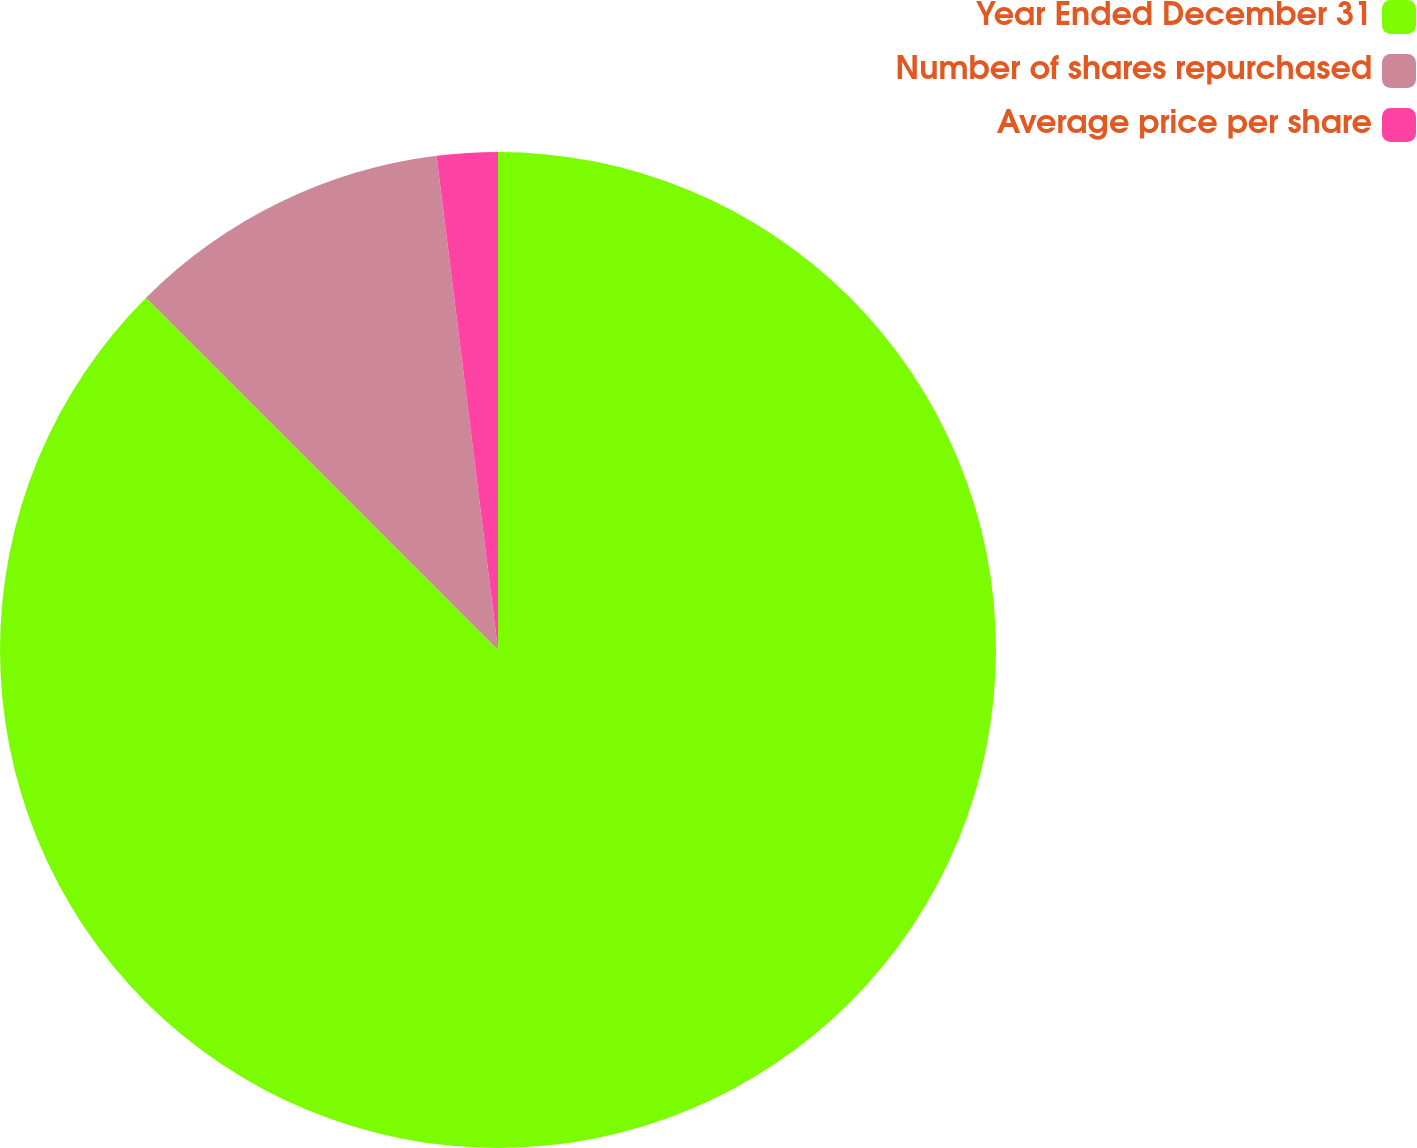Convert chart. <chart><loc_0><loc_0><loc_500><loc_500><pie_chart><fcel>Year Ended December 31<fcel>Number of shares repurchased<fcel>Average price per share<nl><fcel>87.5%<fcel>10.52%<fcel>1.97%<nl></chart> 